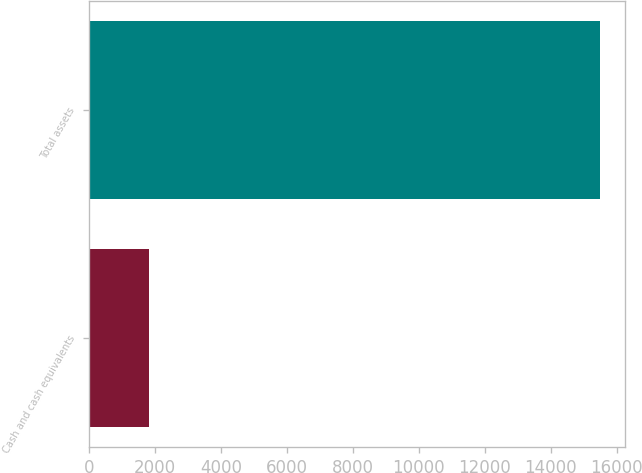<chart> <loc_0><loc_0><loc_500><loc_500><bar_chart><fcel>Cash and cash equivalents<fcel>Total assets<nl><fcel>1832<fcel>15483<nl></chart> 